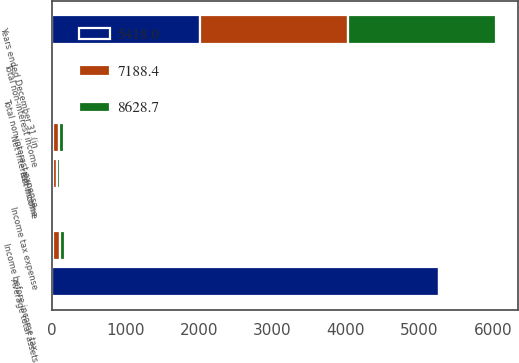<chart> <loc_0><loc_0><loc_500><loc_500><stacked_bar_chart><ecel><fcel>Years ended December 31 (in<fcel>Net interest income<fcel>Total non-interest income<fcel>Total non-interest expense<fcel>Income before income tax<fcel>Income tax expense<fcel>Net income<fcel>Average total assets<nl><fcel>7188.4<fcel>2016<fcel>87.6<fcel>9.2<fcel>9.8<fcel>87<fcel>27.5<fcel>59.5<fcel>25.2<nl><fcel>8628.7<fcel>2015<fcel>64.4<fcel>11.1<fcel>6.9<fcel>68.6<fcel>22.9<fcel>45.7<fcel>25.2<nl><fcel>5418<fcel>2014<fcel>10.7<fcel>12.4<fcel>6.2<fcel>16.9<fcel>5.8<fcel>11.1<fcel>5261.2<nl></chart> 